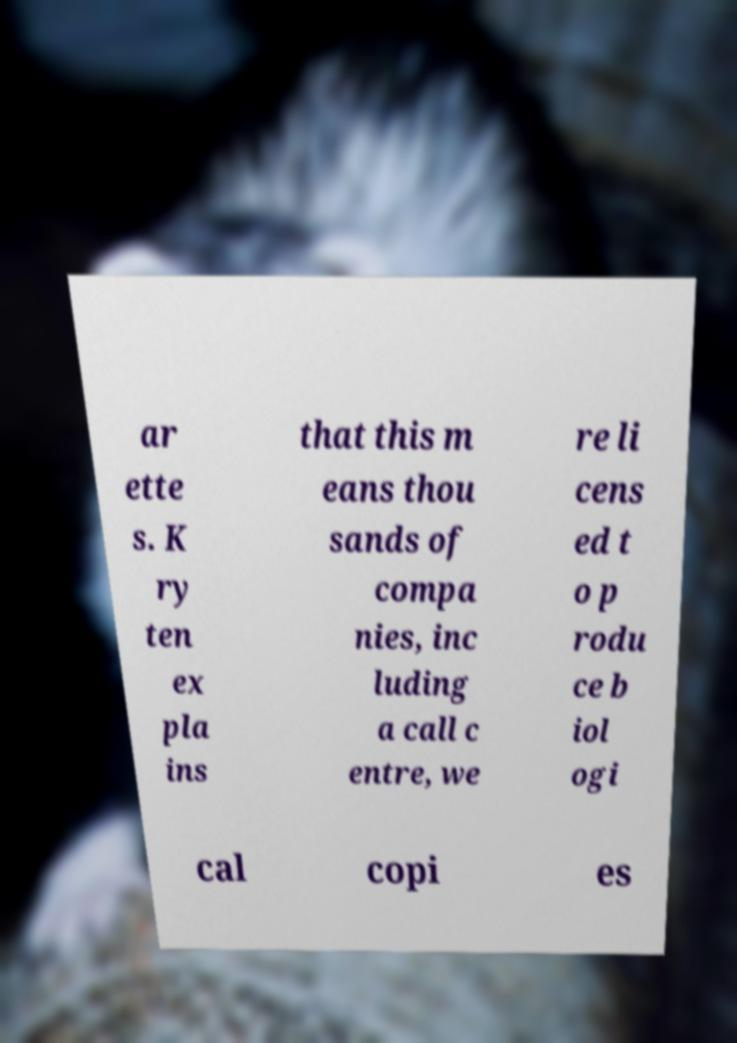Can you accurately transcribe the text from the provided image for me? ar ette s. K ry ten ex pla ins that this m eans thou sands of compa nies, inc luding a call c entre, we re li cens ed t o p rodu ce b iol ogi cal copi es 